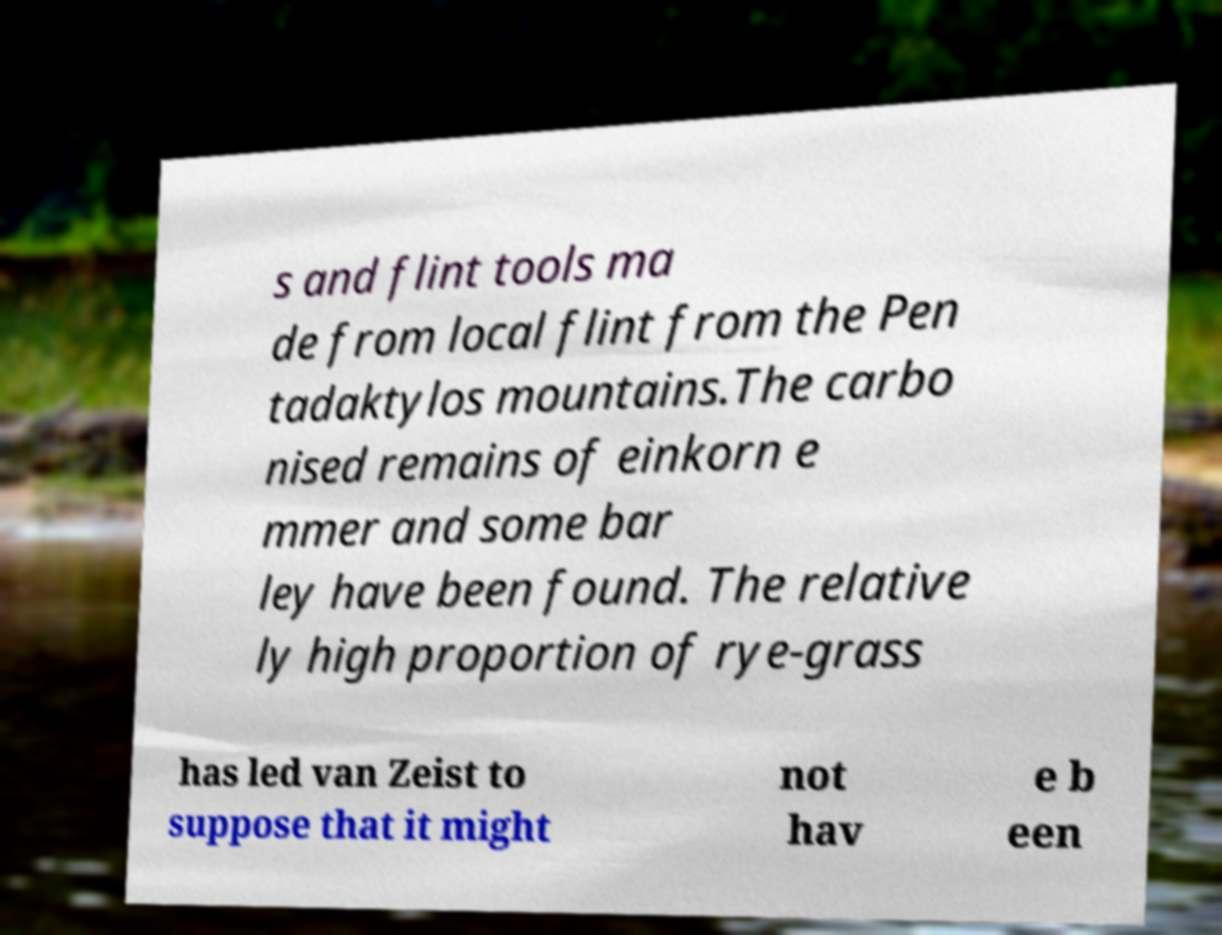Can you accurately transcribe the text from the provided image for me? s and flint tools ma de from local flint from the Pen tadaktylos mountains.The carbo nised remains of einkorn e mmer and some bar ley have been found. The relative ly high proportion of rye-grass has led van Zeist to suppose that it might not hav e b een 